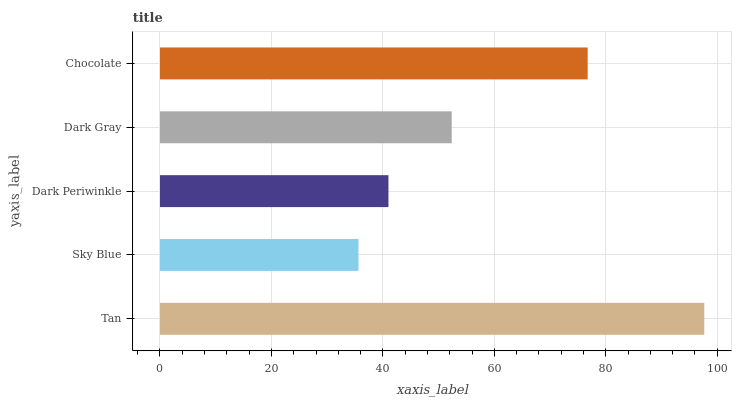Is Sky Blue the minimum?
Answer yes or no. Yes. Is Tan the maximum?
Answer yes or no. Yes. Is Dark Periwinkle the minimum?
Answer yes or no. No. Is Dark Periwinkle the maximum?
Answer yes or no. No. Is Dark Periwinkle greater than Sky Blue?
Answer yes or no. Yes. Is Sky Blue less than Dark Periwinkle?
Answer yes or no. Yes. Is Sky Blue greater than Dark Periwinkle?
Answer yes or no. No. Is Dark Periwinkle less than Sky Blue?
Answer yes or no. No. Is Dark Gray the high median?
Answer yes or no. Yes. Is Dark Gray the low median?
Answer yes or no. Yes. Is Tan the high median?
Answer yes or no. No. Is Dark Periwinkle the low median?
Answer yes or no. No. 